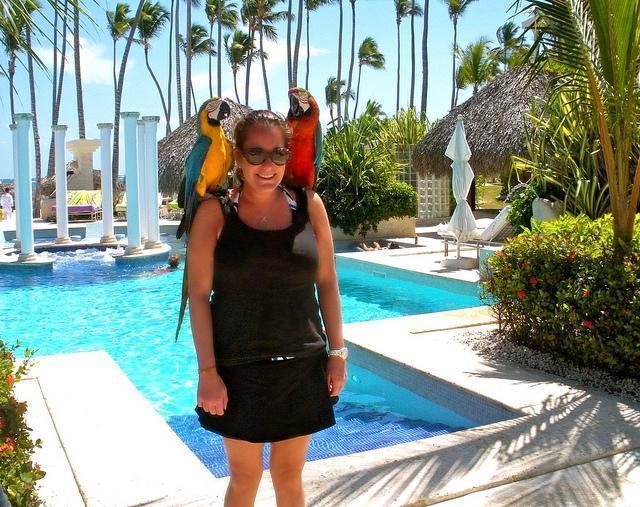How many birds is the woman holding?
Give a very brief answer. 2. How many birds are there?
Give a very brief answer. 2. 